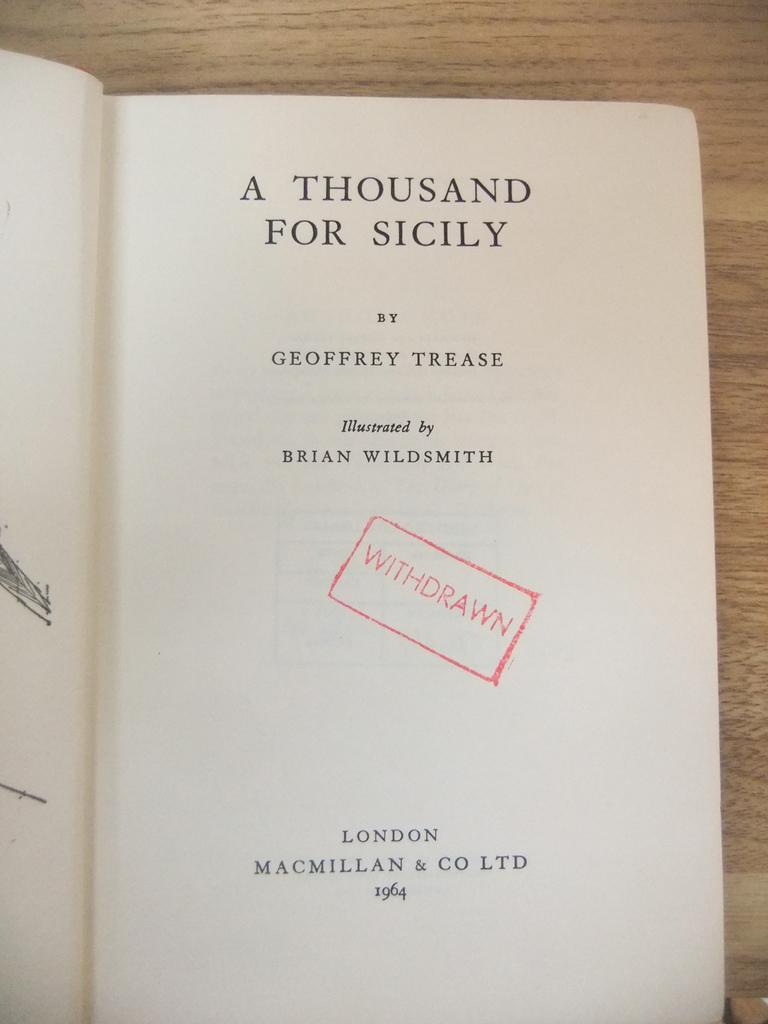What object can be seen in the image? There is a book in the image. What is the state of the book in the image? The book is opened. On what surface is the book placed? The book is placed on a wooden surface. What can be seen inside the book? There is text visible in the book. What type of vegetable is being used as a bookmark in the image? There is no vegetable being used as a bookmark in the image; the book is simply opened and placed on a wooden surface. 